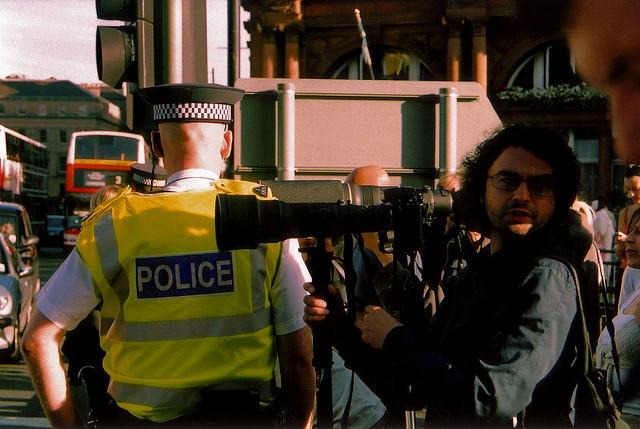What is the occupation of the man wearing a black coat?

Choices:
A) policeman
B) photographer
C) film director
D) news reporter news reporter 